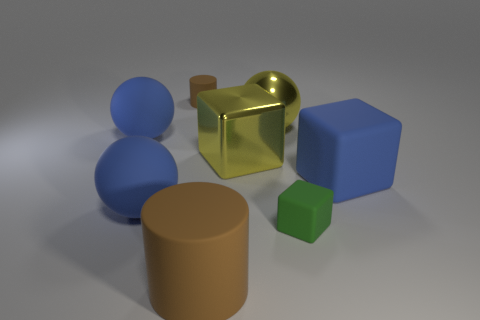Are there any metal blocks of the same size as the green matte thing?
Provide a succinct answer. No. There is another rubber cylinder that is the same color as the large matte cylinder; what size is it?
Offer a terse response. Small. What material is the green cube that is on the right side of the large yellow metallic block?
Provide a short and direct response. Rubber. Are there an equal number of big brown cylinders that are to the left of the small rubber cube and metal balls that are behind the metallic ball?
Ensure brevity in your answer.  No. There is a block that is to the right of the green rubber thing; does it have the same size as the brown rubber object behind the green thing?
Ensure brevity in your answer.  No. What number of other rubber cylinders are the same color as the large cylinder?
Your answer should be very brief. 1. What is the material of the object that is the same color as the large cylinder?
Provide a succinct answer. Rubber. Are there more big blue matte spheres behind the yellow shiny block than small brown matte objects?
Offer a terse response. No. Do the tiny green rubber thing and the big brown matte object have the same shape?
Your answer should be compact. No. How many other blocks are made of the same material as the big blue cube?
Provide a succinct answer. 1. 